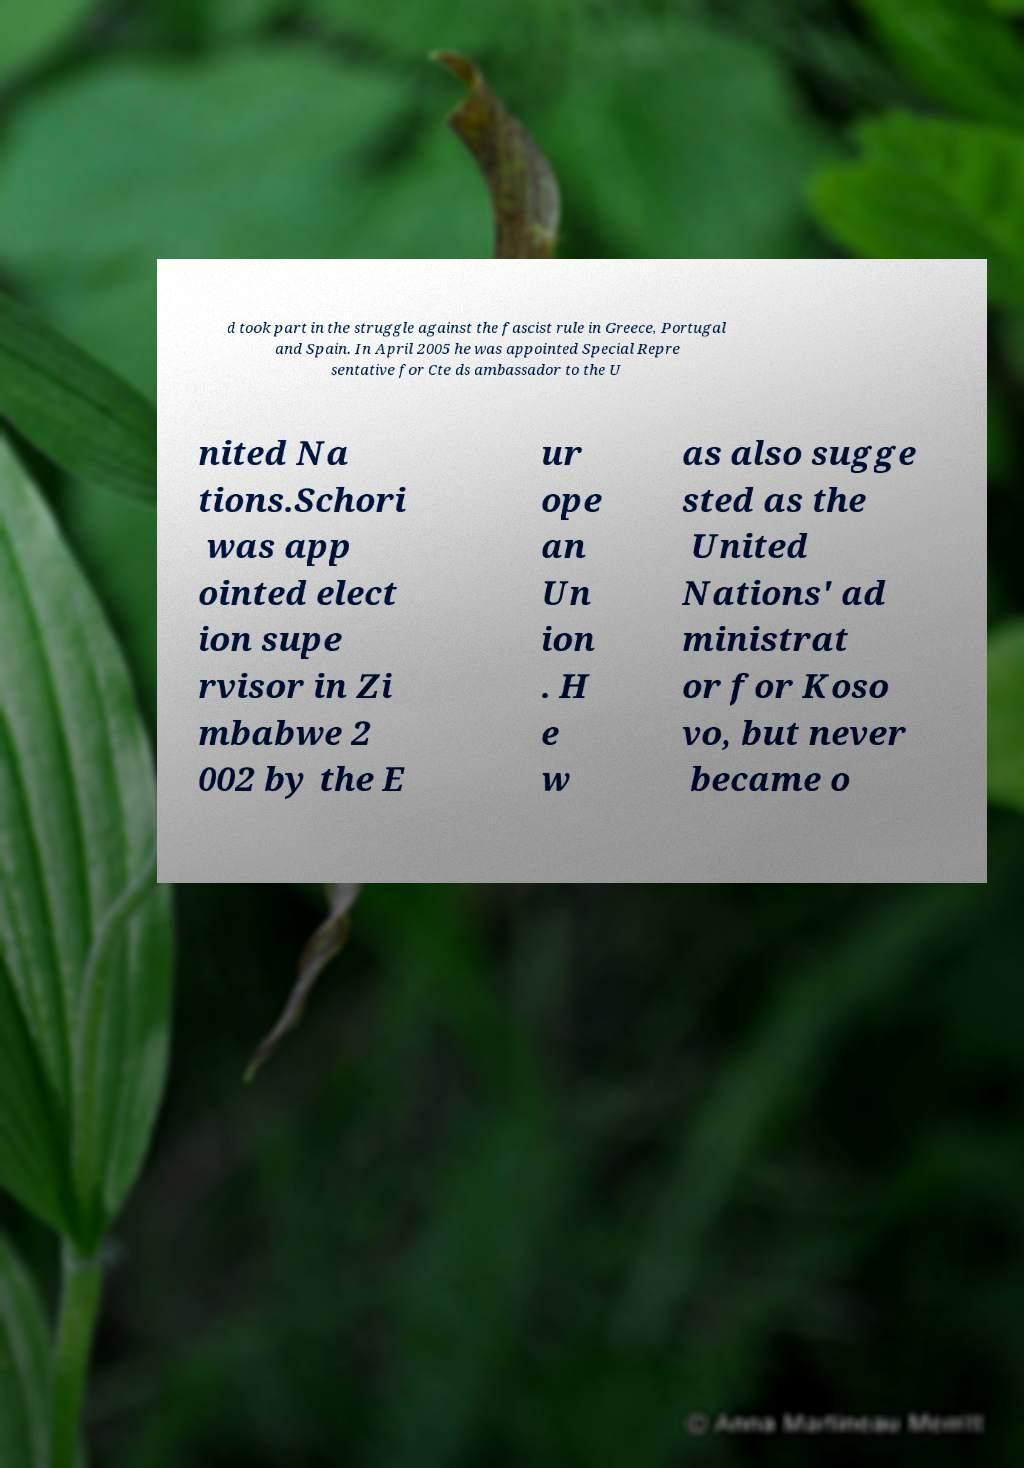What messages or text are displayed in this image? I need them in a readable, typed format. d took part in the struggle against the fascist rule in Greece, Portugal and Spain. In April 2005 he was appointed Special Repre sentative for Cte ds ambassador to the U nited Na tions.Schori was app ointed elect ion supe rvisor in Zi mbabwe 2 002 by the E ur ope an Un ion . H e w as also sugge sted as the United Nations' ad ministrat or for Koso vo, but never became o 